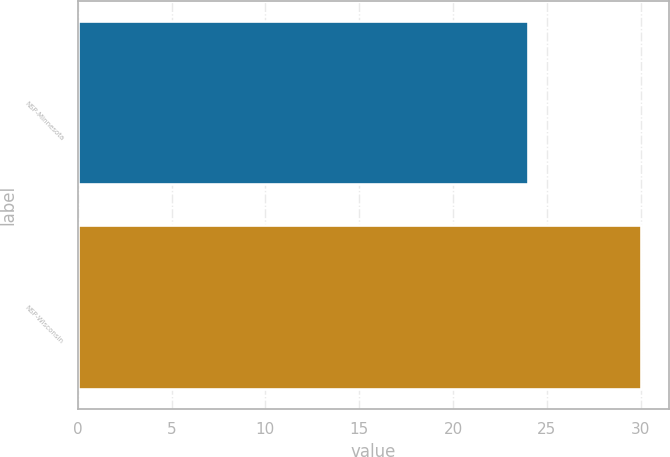Convert chart to OTSL. <chart><loc_0><loc_0><loc_500><loc_500><bar_chart><fcel>NSP-Minnesota<fcel>NSP-Wisconsin<nl><fcel>24<fcel>30<nl></chart> 